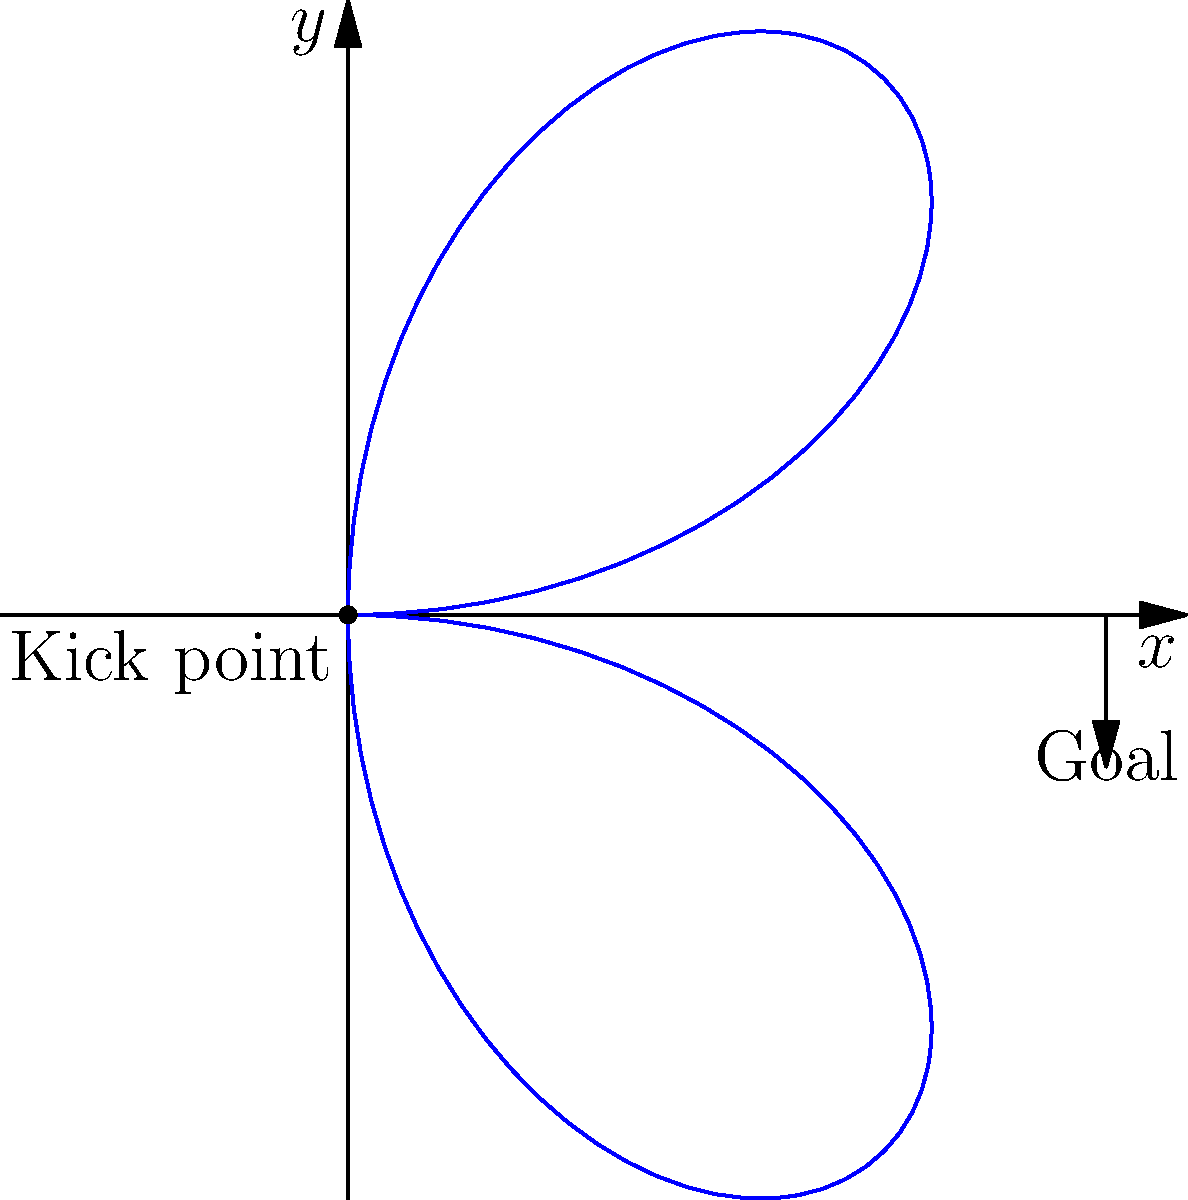At the Burgas Stadium, a local player kicks a soccer ball with a trajectory described by the polar equation $r = 50 \sin(2\theta)$, where $r$ is in meters and $\theta$ is in radians. If the goal is located 50 meters directly in front of the kick point, at what angle(s) $\theta$ does the ball cross the goal line? Let's approach this step-by-step:

1) The goal is located 50 meters directly in front of the kick point, which means it's on the positive x-axis.

2) In polar coordinates, points on the x-axis have $\theta = 0$ or $\theta = \pi$.

3) We need to find where $r = 50$ (the distance to the goal) in our equation:

   $50 = 50 \sin(2\theta)$

4) Simplifying:

   $1 = \sin(2\theta)$

5) The solution to this equation is:

   $2\theta = \frac{\pi}{2}$ or $2\theta = \frac{3\pi}{2}$

6) Solving for $\theta$:

   $\theta = \frac{\pi}{4}$ or $\theta = \frac{3\pi}{4}$

7) These are the angles at which the ball crosses the goal line.
Answer: $\frac{\pi}{4}$ and $\frac{3\pi}{4}$ radians 